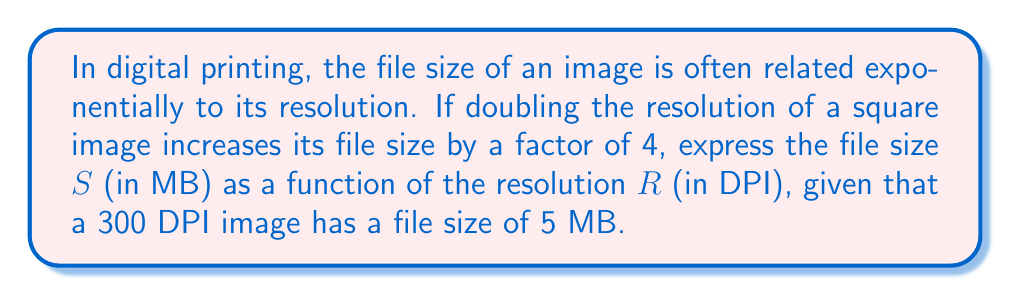Provide a solution to this math problem. 1) Let's start by defining our exponential function:
   $S = a \cdot b^R$
   where $a$ and $b$ are constants we need to determine.

2) We're told that doubling the resolution increases file size by a factor of 4.
   This means: $\frac{S(2R)}{S(R)} = 4$

3) Substituting our function:
   $\frac{a \cdot b^{2R}}{a \cdot b^R} = 4$

4) Simplifying:
   $b^R = 4$

5) Taking the square root of both sides:
   $b^{\frac{R}{2}} = 2$

6) This means $b = 2^{\frac{2}{R}}$, or more simply, $b = \sqrt{2}$

7) Now we know $S = a \cdot (\sqrt{2})^R$

8) We can use the given information that $S(300) = 5$ to find $a$:
   $5 = a \cdot (\sqrt{2})^{300}$

9) Solving for $a$:
   $a = \frac{5}{(\sqrt{2})^{300}}$

10) Our final function is:
    $S = \frac{5}{(\sqrt{2})^{300}} \cdot (\sqrt{2})^R$

11) This can be simplified to:
    $S = 5 \cdot (\sqrt{2})^{R-300}$
Answer: $S = 5 \cdot (\sqrt{2})^{R-300}$ 